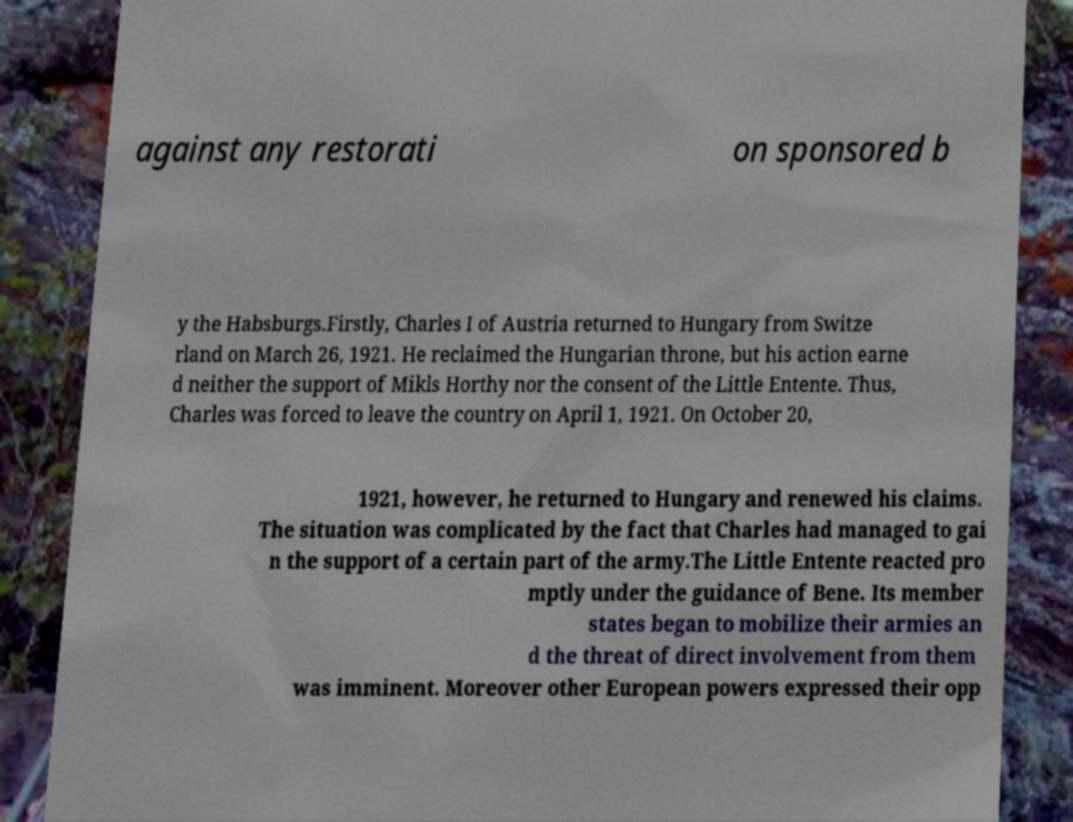What messages or text are displayed in this image? I need them in a readable, typed format. against any restorati on sponsored b y the Habsburgs.Firstly, Charles I of Austria returned to Hungary from Switze rland on March 26, 1921. He reclaimed the Hungarian throne, but his action earne d neither the support of Mikls Horthy nor the consent of the Little Entente. Thus, Charles was forced to leave the country on April 1, 1921. On October 20, 1921, however, he returned to Hungary and renewed his claims. The situation was complicated by the fact that Charles had managed to gai n the support of a certain part of the army.The Little Entente reacted pro mptly under the guidance of Bene. Its member states began to mobilize their armies an d the threat of direct involvement from them was imminent. Moreover other European powers expressed their opp 